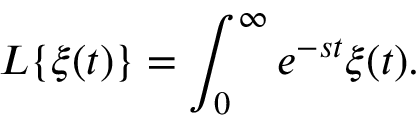<formula> <loc_0><loc_0><loc_500><loc_500>L \{ \xi ( t ) \} = \int _ { 0 } ^ { \infty } e ^ { - s t } \xi ( t ) .</formula> 